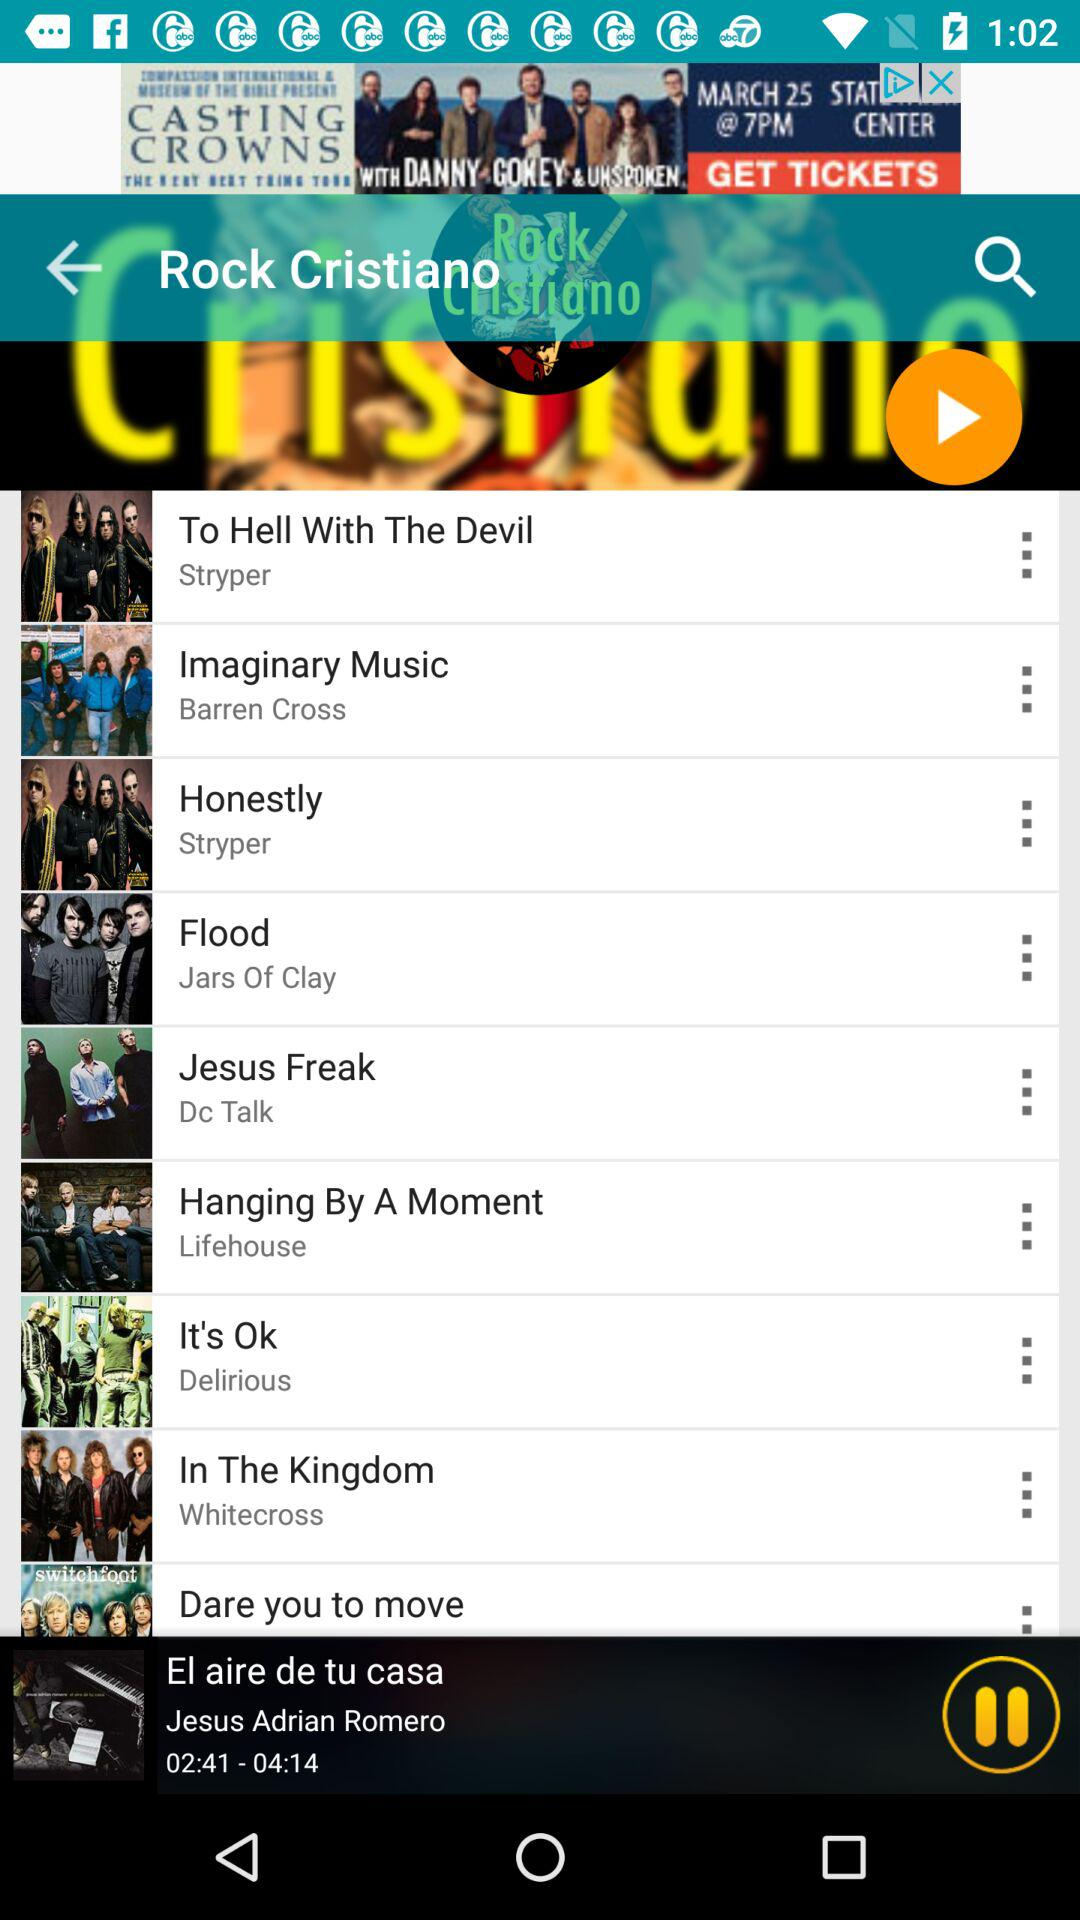What is the duration of the audio? The duration of the audio is 04:14. 